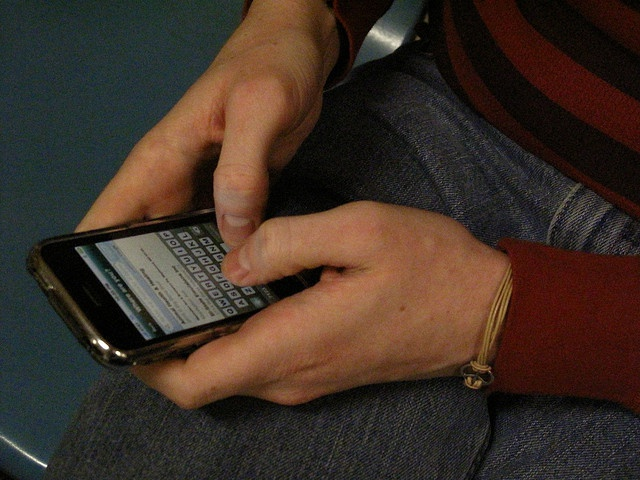Describe the objects in this image and their specific colors. I can see people in black, brown, and maroon tones, chair in black, darkblue, gray, and purple tones, and cell phone in black, gray, and maroon tones in this image. 